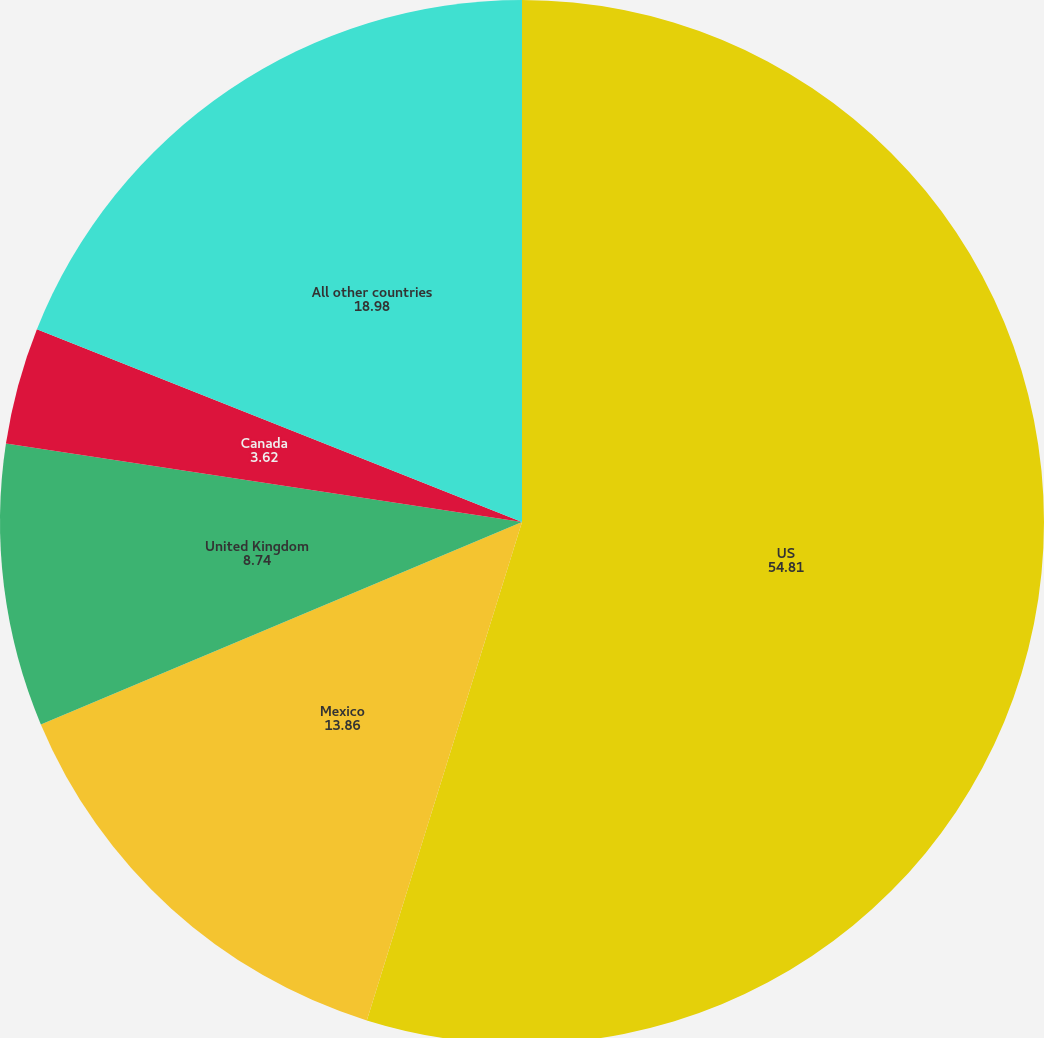Convert chart. <chart><loc_0><loc_0><loc_500><loc_500><pie_chart><fcel>US<fcel>Mexico<fcel>United Kingdom<fcel>Canada<fcel>All other countries<nl><fcel>54.81%<fcel>13.86%<fcel>8.74%<fcel>3.62%<fcel>18.98%<nl></chart> 